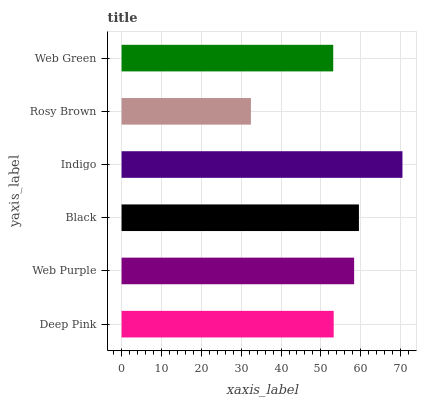Is Rosy Brown the minimum?
Answer yes or no. Yes. Is Indigo the maximum?
Answer yes or no. Yes. Is Web Purple the minimum?
Answer yes or no. No. Is Web Purple the maximum?
Answer yes or no. No. Is Web Purple greater than Deep Pink?
Answer yes or no. Yes. Is Deep Pink less than Web Purple?
Answer yes or no. Yes. Is Deep Pink greater than Web Purple?
Answer yes or no. No. Is Web Purple less than Deep Pink?
Answer yes or no. No. Is Web Purple the high median?
Answer yes or no. Yes. Is Deep Pink the low median?
Answer yes or no. Yes. Is Rosy Brown the high median?
Answer yes or no. No. Is Black the low median?
Answer yes or no. No. 